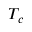<formula> <loc_0><loc_0><loc_500><loc_500>T _ { c }</formula> 